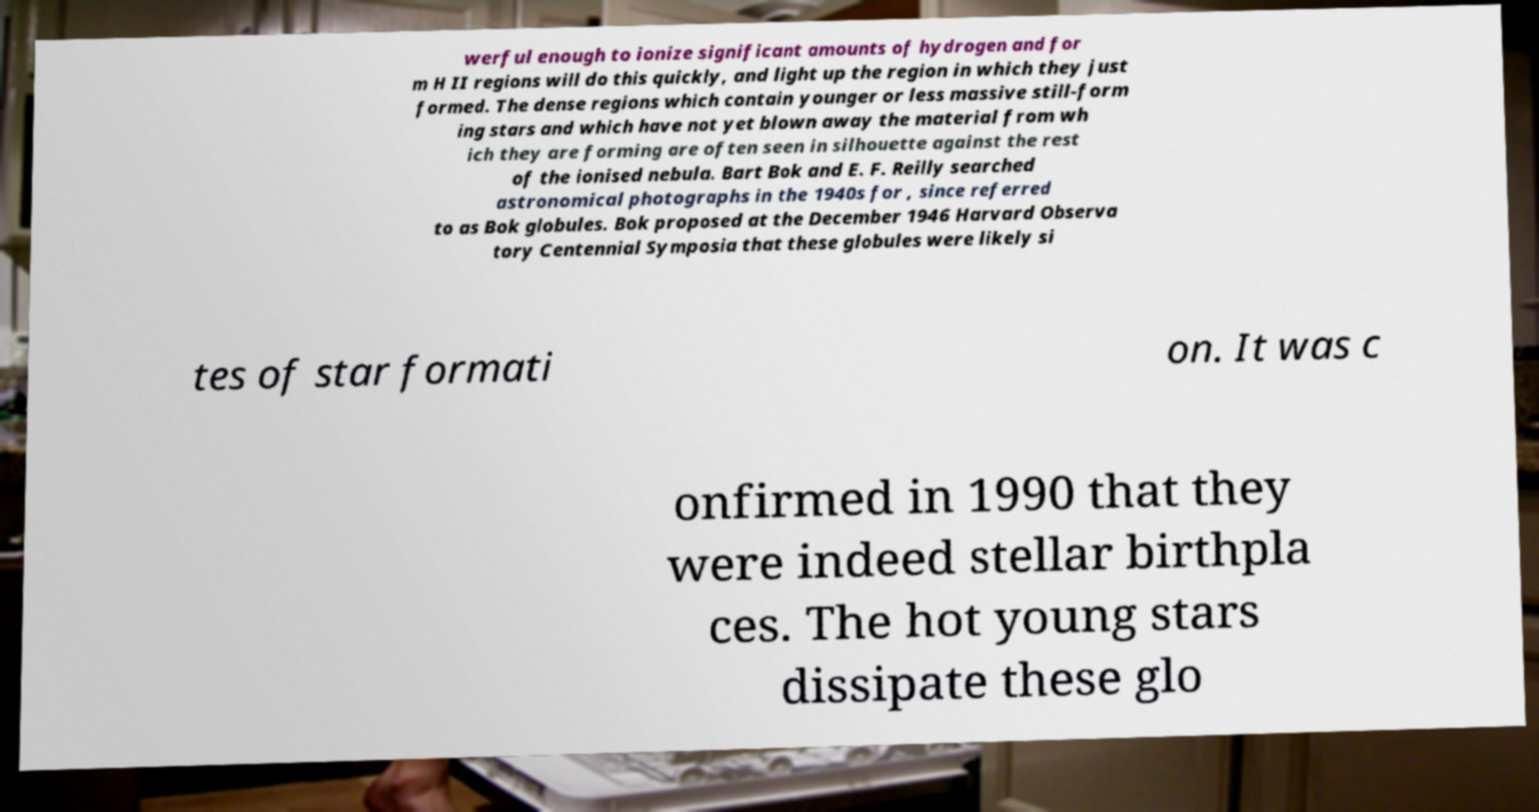Can you read and provide the text displayed in the image?This photo seems to have some interesting text. Can you extract and type it out for me? werful enough to ionize significant amounts of hydrogen and for m H II regions will do this quickly, and light up the region in which they just formed. The dense regions which contain younger or less massive still-form ing stars and which have not yet blown away the material from wh ich they are forming are often seen in silhouette against the rest of the ionised nebula. Bart Bok and E. F. Reilly searched astronomical photographs in the 1940s for , since referred to as Bok globules. Bok proposed at the December 1946 Harvard Observa tory Centennial Symposia that these globules were likely si tes of star formati on. It was c onfirmed in 1990 that they were indeed stellar birthpla ces. The hot young stars dissipate these glo 